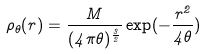Convert formula to latex. <formula><loc_0><loc_0><loc_500><loc_500>\rho _ { \theta } ( r ) = \frac { M } { ( 4 \pi \theta ) ^ { \frac { 3 } { 2 } } } \exp ( - \frac { r ^ { 2 } } { 4 \theta } )</formula> 